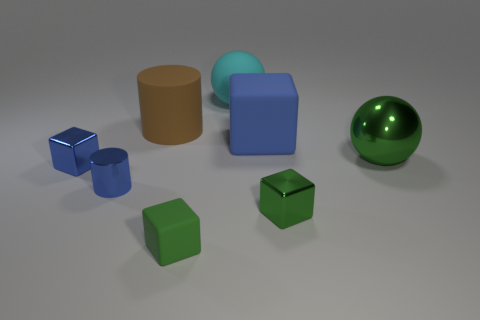Subtract all tiny cubes. How many cubes are left? 1 Add 1 small blue metal cubes. How many objects exist? 9 Subtract all cylinders. How many objects are left? 6 Subtract 2 spheres. How many spheres are left? 0 Subtract all cyan cubes. Subtract all purple cylinders. How many cubes are left? 4 Subtract all red cylinders. How many purple spheres are left? 0 Subtract all small gray matte objects. Subtract all blue matte things. How many objects are left? 7 Add 3 big rubber balls. How many big rubber balls are left? 4 Add 4 blocks. How many blocks exist? 8 Subtract all blue blocks. How many blocks are left? 2 